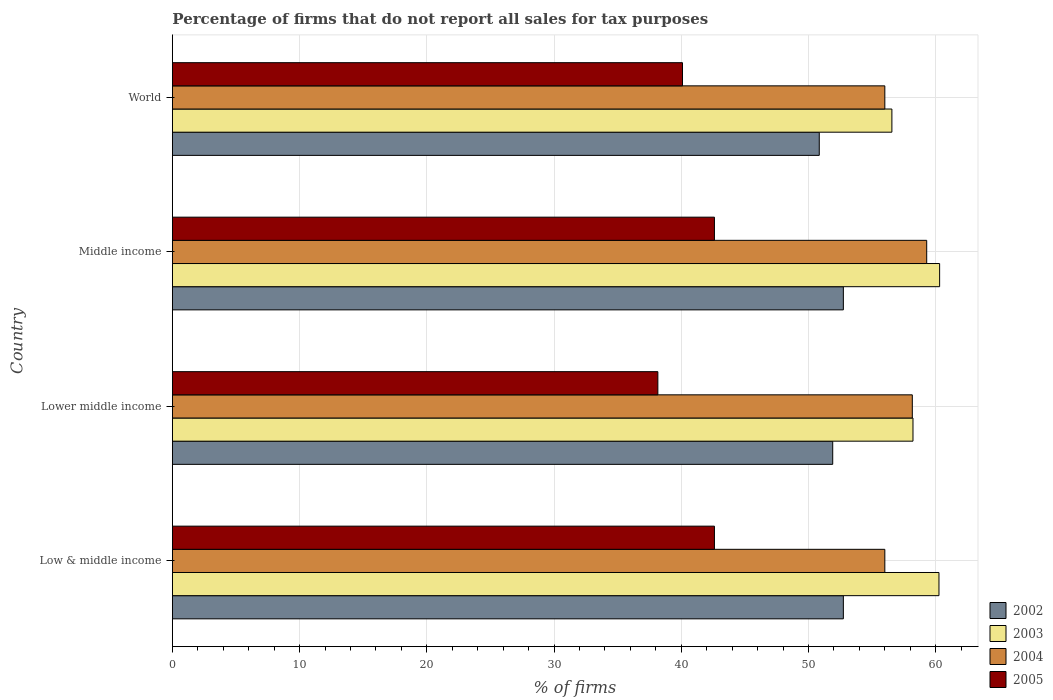How many different coloured bars are there?
Provide a succinct answer. 4. How many groups of bars are there?
Offer a terse response. 4. Are the number of bars per tick equal to the number of legend labels?
Offer a very short reply. Yes. Are the number of bars on each tick of the Y-axis equal?
Make the answer very short. Yes. How many bars are there on the 4th tick from the bottom?
Your answer should be very brief. 4. What is the label of the 1st group of bars from the top?
Offer a very short reply. World. In how many cases, is the number of bars for a given country not equal to the number of legend labels?
Provide a short and direct response. 0. What is the percentage of firms that do not report all sales for tax purposes in 2003 in Middle income?
Your answer should be very brief. 60.31. Across all countries, what is the maximum percentage of firms that do not report all sales for tax purposes in 2004?
Offer a terse response. 59.3. Across all countries, what is the minimum percentage of firms that do not report all sales for tax purposes in 2004?
Ensure brevity in your answer.  56.01. In which country was the percentage of firms that do not report all sales for tax purposes in 2004 maximum?
Offer a very short reply. Middle income. In which country was the percentage of firms that do not report all sales for tax purposes in 2003 minimum?
Your response must be concise. World. What is the total percentage of firms that do not report all sales for tax purposes in 2002 in the graph?
Keep it short and to the point. 208.25. What is the difference between the percentage of firms that do not report all sales for tax purposes in 2003 in Lower middle income and that in World?
Keep it short and to the point. 1.66. What is the difference between the percentage of firms that do not report all sales for tax purposes in 2005 in Middle income and the percentage of firms that do not report all sales for tax purposes in 2003 in Low & middle income?
Offer a terse response. -17.65. What is the average percentage of firms that do not report all sales for tax purposes in 2004 per country?
Give a very brief answer. 57.37. What is the difference between the percentage of firms that do not report all sales for tax purposes in 2004 and percentage of firms that do not report all sales for tax purposes in 2005 in Lower middle income?
Keep it short and to the point. 20. What is the ratio of the percentage of firms that do not report all sales for tax purposes in 2002 in Low & middle income to that in Lower middle income?
Your answer should be compact. 1.02. Is the percentage of firms that do not report all sales for tax purposes in 2003 in Lower middle income less than that in World?
Offer a terse response. No. What is the difference between the highest and the second highest percentage of firms that do not report all sales for tax purposes in 2002?
Ensure brevity in your answer.  0. What is the difference between the highest and the lowest percentage of firms that do not report all sales for tax purposes in 2003?
Offer a very short reply. 3.75. Is it the case that in every country, the sum of the percentage of firms that do not report all sales for tax purposes in 2002 and percentage of firms that do not report all sales for tax purposes in 2004 is greater than the sum of percentage of firms that do not report all sales for tax purposes in 2005 and percentage of firms that do not report all sales for tax purposes in 2003?
Give a very brief answer. Yes. What does the 1st bar from the top in Middle income represents?
Offer a very short reply. 2005. Is it the case that in every country, the sum of the percentage of firms that do not report all sales for tax purposes in 2005 and percentage of firms that do not report all sales for tax purposes in 2002 is greater than the percentage of firms that do not report all sales for tax purposes in 2004?
Provide a short and direct response. Yes. How many bars are there?
Make the answer very short. 16. Are all the bars in the graph horizontal?
Make the answer very short. Yes. What is the difference between two consecutive major ticks on the X-axis?
Offer a very short reply. 10. Are the values on the major ticks of X-axis written in scientific E-notation?
Your response must be concise. No. Does the graph contain grids?
Provide a short and direct response. Yes. What is the title of the graph?
Give a very brief answer. Percentage of firms that do not report all sales for tax purposes. What is the label or title of the X-axis?
Your answer should be compact. % of firms. What is the label or title of the Y-axis?
Make the answer very short. Country. What is the % of firms of 2002 in Low & middle income?
Keep it short and to the point. 52.75. What is the % of firms of 2003 in Low & middle income?
Your answer should be very brief. 60.26. What is the % of firms of 2004 in Low & middle income?
Keep it short and to the point. 56.01. What is the % of firms of 2005 in Low & middle income?
Give a very brief answer. 42.61. What is the % of firms in 2002 in Lower middle income?
Your answer should be compact. 51.91. What is the % of firms in 2003 in Lower middle income?
Your answer should be compact. 58.22. What is the % of firms of 2004 in Lower middle income?
Give a very brief answer. 58.16. What is the % of firms in 2005 in Lower middle income?
Offer a terse response. 38.16. What is the % of firms of 2002 in Middle income?
Ensure brevity in your answer.  52.75. What is the % of firms in 2003 in Middle income?
Provide a succinct answer. 60.31. What is the % of firms in 2004 in Middle income?
Offer a very short reply. 59.3. What is the % of firms of 2005 in Middle income?
Provide a succinct answer. 42.61. What is the % of firms in 2002 in World?
Keep it short and to the point. 50.85. What is the % of firms in 2003 in World?
Your answer should be compact. 56.56. What is the % of firms in 2004 in World?
Keep it short and to the point. 56.01. What is the % of firms in 2005 in World?
Your response must be concise. 40.1. Across all countries, what is the maximum % of firms of 2002?
Keep it short and to the point. 52.75. Across all countries, what is the maximum % of firms in 2003?
Give a very brief answer. 60.31. Across all countries, what is the maximum % of firms of 2004?
Ensure brevity in your answer.  59.3. Across all countries, what is the maximum % of firms in 2005?
Offer a terse response. 42.61. Across all countries, what is the minimum % of firms in 2002?
Your answer should be very brief. 50.85. Across all countries, what is the minimum % of firms of 2003?
Offer a terse response. 56.56. Across all countries, what is the minimum % of firms in 2004?
Give a very brief answer. 56.01. Across all countries, what is the minimum % of firms of 2005?
Offer a very short reply. 38.16. What is the total % of firms of 2002 in the graph?
Ensure brevity in your answer.  208.25. What is the total % of firms of 2003 in the graph?
Your answer should be very brief. 235.35. What is the total % of firms in 2004 in the graph?
Keep it short and to the point. 229.47. What is the total % of firms in 2005 in the graph?
Your answer should be very brief. 163.48. What is the difference between the % of firms in 2002 in Low & middle income and that in Lower middle income?
Provide a short and direct response. 0.84. What is the difference between the % of firms of 2003 in Low & middle income and that in Lower middle income?
Your answer should be compact. 2.04. What is the difference between the % of firms in 2004 in Low & middle income and that in Lower middle income?
Provide a short and direct response. -2.16. What is the difference between the % of firms in 2005 in Low & middle income and that in Lower middle income?
Your answer should be compact. 4.45. What is the difference between the % of firms in 2003 in Low & middle income and that in Middle income?
Make the answer very short. -0.05. What is the difference between the % of firms of 2004 in Low & middle income and that in Middle income?
Provide a succinct answer. -3.29. What is the difference between the % of firms of 2005 in Low & middle income and that in Middle income?
Your answer should be very brief. 0. What is the difference between the % of firms of 2002 in Low & middle income and that in World?
Keep it short and to the point. 1.89. What is the difference between the % of firms in 2003 in Low & middle income and that in World?
Your answer should be compact. 3.7. What is the difference between the % of firms in 2005 in Low & middle income and that in World?
Your answer should be compact. 2.51. What is the difference between the % of firms of 2002 in Lower middle income and that in Middle income?
Ensure brevity in your answer.  -0.84. What is the difference between the % of firms in 2003 in Lower middle income and that in Middle income?
Provide a succinct answer. -2.09. What is the difference between the % of firms in 2004 in Lower middle income and that in Middle income?
Give a very brief answer. -1.13. What is the difference between the % of firms of 2005 in Lower middle income and that in Middle income?
Your response must be concise. -4.45. What is the difference between the % of firms in 2002 in Lower middle income and that in World?
Your answer should be very brief. 1.06. What is the difference between the % of firms of 2003 in Lower middle income and that in World?
Provide a short and direct response. 1.66. What is the difference between the % of firms of 2004 in Lower middle income and that in World?
Give a very brief answer. 2.16. What is the difference between the % of firms in 2005 in Lower middle income and that in World?
Provide a short and direct response. -1.94. What is the difference between the % of firms of 2002 in Middle income and that in World?
Provide a short and direct response. 1.89. What is the difference between the % of firms in 2003 in Middle income and that in World?
Your response must be concise. 3.75. What is the difference between the % of firms in 2004 in Middle income and that in World?
Keep it short and to the point. 3.29. What is the difference between the % of firms in 2005 in Middle income and that in World?
Your answer should be compact. 2.51. What is the difference between the % of firms in 2002 in Low & middle income and the % of firms in 2003 in Lower middle income?
Offer a very short reply. -5.47. What is the difference between the % of firms of 2002 in Low & middle income and the % of firms of 2004 in Lower middle income?
Give a very brief answer. -5.42. What is the difference between the % of firms of 2002 in Low & middle income and the % of firms of 2005 in Lower middle income?
Ensure brevity in your answer.  14.58. What is the difference between the % of firms of 2003 in Low & middle income and the % of firms of 2004 in Lower middle income?
Keep it short and to the point. 2.1. What is the difference between the % of firms in 2003 in Low & middle income and the % of firms in 2005 in Lower middle income?
Provide a short and direct response. 22.1. What is the difference between the % of firms of 2004 in Low & middle income and the % of firms of 2005 in Lower middle income?
Your answer should be compact. 17.84. What is the difference between the % of firms of 2002 in Low & middle income and the % of firms of 2003 in Middle income?
Offer a very short reply. -7.57. What is the difference between the % of firms of 2002 in Low & middle income and the % of firms of 2004 in Middle income?
Provide a succinct answer. -6.55. What is the difference between the % of firms in 2002 in Low & middle income and the % of firms in 2005 in Middle income?
Your response must be concise. 10.13. What is the difference between the % of firms in 2003 in Low & middle income and the % of firms in 2005 in Middle income?
Provide a succinct answer. 17.65. What is the difference between the % of firms in 2004 in Low & middle income and the % of firms in 2005 in Middle income?
Keep it short and to the point. 13.39. What is the difference between the % of firms in 2002 in Low & middle income and the % of firms in 2003 in World?
Ensure brevity in your answer.  -3.81. What is the difference between the % of firms in 2002 in Low & middle income and the % of firms in 2004 in World?
Provide a short and direct response. -3.26. What is the difference between the % of firms of 2002 in Low & middle income and the % of firms of 2005 in World?
Your response must be concise. 12.65. What is the difference between the % of firms in 2003 in Low & middle income and the % of firms in 2004 in World?
Give a very brief answer. 4.25. What is the difference between the % of firms in 2003 in Low & middle income and the % of firms in 2005 in World?
Provide a short and direct response. 20.16. What is the difference between the % of firms of 2004 in Low & middle income and the % of firms of 2005 in World?
Your response must be concise. 15.91. What is the difference between the % of firms in 2002 in Lower middle income and the % of firms in 2003 in Middle income?
Your response must be concise. -8.4. What is the difference between the % of firms of 2002 in Lower middle income and the % of firms of 2004 in Middle income?
Keep it short and to the point. -7.39. What is the difference between the % of firms in 2002 in Lower middle income and the % of firms in 2005 in Middle income?
Provide a succinct answer. 9.3. What is the difference between the % of firms of 2003 in Lower middle income and the % of firms of 2004 in Middle income?
Your answer should be compact. -1.08. What is the difference between the % of firms in 2003 in Lower middle income and the % of firms in 2005 in Middle income?
Your response must be concise. 15.61. What is the difference between the % of firms in 2004 in Lower middle income and the % of firms in 2005 in Middle income?
Your response must be concise. 15.55. What is the difference between the % of firms of 2002 in Lower middle income and the % of firms of 2003 in World?
Keep it short and to the point. -4.65. What is the difference between the % of firms in 2002 in Lower middle income and the % of firms in 2004 in World?
Keep it short and to the point. -4.1. What is the difference between the % of firms of 2002 in Lower middle income and the % of firms of 2005 in World?
Your response must be concise. 11.81. What is the difference between the % of firms of 2003 in Lower middle income and the % of firms of 2004 in World?
Keep it short and to the point. 2.21. What is the difference between the % of firms in 2003 in Lower middle income and the % of firms in 2005 in World?
Provide a short and direct response. 18.12. What is the difference between the % of firms of 2004 in Lower middle income and the % of firms of 2005 in World?
Offer a terse response. 18.07. What is the difference between the % of firms of 2002 in Middle income and the % of firms of 2003 in World?
Keep it short and to the point. -3.81. What is the difference between the % of firms of 2002 in Middle income and the % of firms of 2004 in World?
Offer a very short reply. -3.26. What is the difference between the % of firms of 2002 in Middle income and the % of firms of 2005 in World?
Give a very brief answer. 12.65. What is the difference between the % of firms in 2003 in Middle income and the % of firms in 2004 in World?
Provide a succinct answer. 4.31. What is the difference between the % of firms in 2003 in Middle income and the % of firms in 2005 in World?
Give a very brief answer. 20.21. What is the difference between the % of firms in 2004 in Middle income and the % of firms in 2005 in World?
Your answer should be very brief. 19.2. What is the average % of firms in 2002 per country?
Ensure brevity in your answer.  52.06. What is the average % of firms of 2003 per country?
Ensure brevity in your answer.  58.84. What is the average % of firms in 2004 per country?
Make the answer very short. 57.37. What is the average % of firms in 2005 per country?
Offer a terse response. 40.87. What is the difference between the % of firms of 2002 and % of firms of 2003 in Low & middle income?
Make the answer very short. -7.51. What is the difference between the % of firms in 2002 and % of firms in 2004 in Low & middle income?
Provide a succinct answer. -3.26. What is the difference between the % of firms in 2002 and % of firms in 2005 in Low & middle income?
Provide a short and direct response. 10.13. What is the difference between the % of firms in 2003 and % of firms in 2004 in Low & middle income?
Make the answer very short. 4.25. What is the difference between the % of firms of 2003 and % of firms of 2005 in Low & middle income?
Provide a short and direct response. 17.65. What is the difference between the % of firms of 2004 and % of firms of 2005 in Low & middle income?
Ensure brevity in your answer.  13.39. What is the difference between the % of firms of 2002 and % of firms of 2003 in Lower middle income?
Provide a succinct answer. -6.31. What is the difference between the % of firms in 2002 and % of firms in 2004 in Lower middle income?
Provide a succinct answer. -6.26. What is the difference between the % of firms of 2002 and % of firms of 2005 in Lower middle income?
Your response must be concise. 13.75. What is the difference between the % of firms of 2003 and % of firms of 2004 in Lower middle income?
Make the answer very short. 0.05. What is the difference between the % of firms of 2003 and % of firms of 2005 in Lower middle income?
Ensure brevity in your answer.  20.06. What is the difference between the % of firms of 2004 and % of firms of 2005 in Lower middle income?
Your answer should be very brief. 20. What is the difference between the % of firms in 2002 and % of firms in 2003 in Middle income?
Your response must be concise. -7.57. What is the difference between the % of firms in 2002 and % of firms in 2004 in Middle income?
Offer a terse response. -6.55. What is the difference between the % of firms of 2002 and % of firms of 2005 in Middle income?
Your answer should be very brief. 10.13. What is the difference between the % of firms in 2003 and % of firms in 2004 in Middle income?
Your answer should be compact. 1.02. What is the difference between the % of firms in 2003 and % of firms in 2005 in Middle income?
Offer a very short reply. 17.7. What is the difference between the % of firms in 2004 and % of firms in 2005 in Middle income?
Your response must be concise. 16.69. What is the difference between the % of firms of 2002 and % of firms of 2003 in World?
Keep it short and to the point. -5.71. What is the difference between the % of firms of 2002 and % of firms of 2004 in World?
Make the answer very short. -5.15. What is the difference between the % of firms in 2002 and % of firms in 2005 in World?
Give a very brief answer. 10.75. What is the difference between the % of firms of 2003 and % of firms of 2004 in World?
Make the answer very short. 0.56. What is the difference between the % of firms in 2003 and % of firms in 2005 in World?
Your answer should be very brief. 16.46. What is the difference between the % of firms in 2004 and % of firms in 2005 in World?
Make the answer very short. 15.91. What is the ratio of the % of firms in 2002 in Low & middle income to that in Lower middle income?
Provide a short and direct response. 1.02. What is the ratio of the % of firms in 2003 in Low & middle income to that in Lower middle income?
Keep it short and to the point. 1.04. What is the ratio of the % of firms in 2004 in Low & middle income to that in Lower middle income?
Your answer should be compact. 0.96. What is the ratio of the % of firms of 2005 in Low & middle income to that in Lower middle income?
Keep it short and to the point. 1.12. What is the ratio of the % of firms of 2002 in Low & middle income to that in Middle income?
Offer a terse response. 1. What is the ratio of the % of firms of 2004 in Low & middle income to that in Middle income?
Your answer should be compact. 0.94. What is the ratio of the % of firms of 2005 in Low & middle income to that in Middle income?
Your answer should be very brief. 1. What is the ratio of the % of firms in 2002 in Low & middle income to that in World?
Ensure brevity in your answer.  1.04. What is the ratio of the % of firms of 2003 in Low & middle income to that in World?
Offer a very short reply. 1.07. What is the ratio of the % of firms in 2005 in Low & middle income to that in World?
Keep it short and to the point. 1.06. What is the ratio of the % of firms in 2002 in Lower middle income to that in Middle income?
Keep it short and to the point. 0.98. What is the ratio of the % of firms of 2003 in Lower middle income to that in Middle income?
Your response must be concise. 0.97. What is the ratio of the % of firms of 2004 in Lower middle income to that in Middle income?
Offer a terse response. 0.98. What is the ratio of the % of firms of 2005 in Lower middle income to that in Middle income?
Your answer should be compact. 0.9. What is the ratio of the % of firms of 2002 in Lower middle income to that in World?
Give a very brief answer. 1.02. What is the ratio of the % of firms in 2003 in Lower middle income to that in World?
Keep it short and to the point. 1.03. What is the ratio of the % of firms of 2004 in Lower middle income to that in World?
Your response must be concise. 1.04. What is the ratio of the % of firms in 2005 in Lower middle income to that in World?
Keep it short and to the point. 0.95. What is the ratio of the % of firms of 2002 in Middle income to that in World?
Make the answer very short. 1.04. What is the ratio of the % of firms in 2003 in Middle income to that in World?
Give a very brief answer. 1.07. What is the ratio of the % of firms in 2004 in Middle income to that in World?
Offer a very short reply. 1.06. What is the ratio of the % of firms of 2005 in Middle income to that in World?
Ensure brevity in your answer.  1.06. What is the difference between the highest and the second highest % of firms of 2003?
Offer a terse response. 0.05. What is the difference between the highest and the second highest % of firms of 2004?
Offer a very short reply. 1.13. What is the difference between the highest and the lowest % of firms in 2002?
Ensure brevity in your answer.  1.89. What is the difference between the highest and the lowest % of firms in 2003?
Offer a very short reply. 3.75. What is the difference between the highest and the lowest % of firms in 2004?
Offer a terse response. 3.29. What is the difference between the highest and the lowest % of firms of 2005?
Your response must be concise. 4.45. 